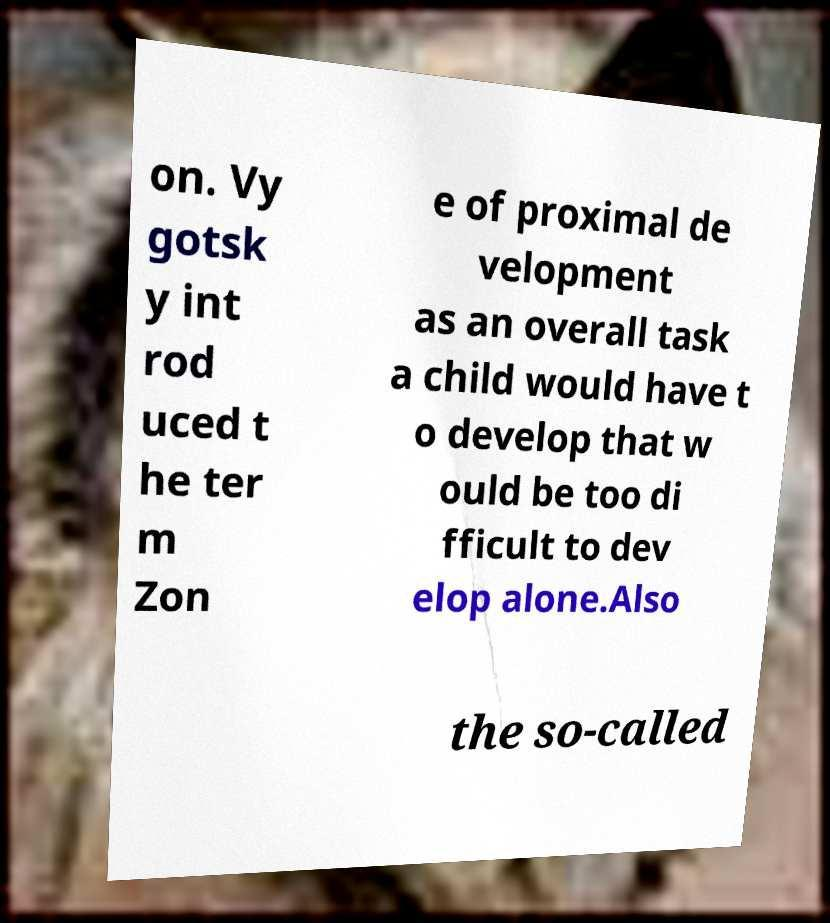Please identify and transcribe the text found in this image. on. Vy gotsk y int rod uced t he ter m Zon e of proximal de velopment as an overall task a child would have t o develop that w ould be too di fficult to dev elop alone.Also the so-called 